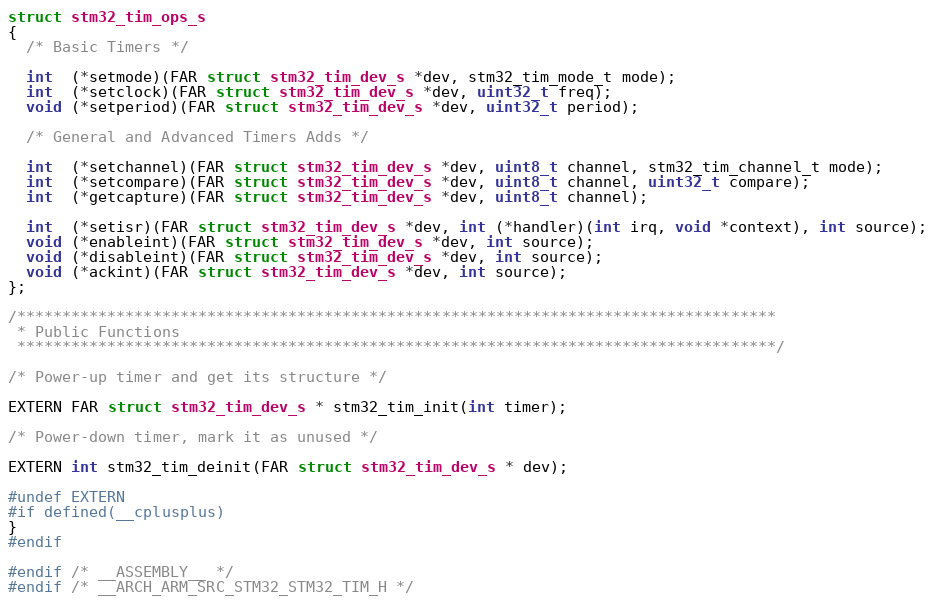<code> <loc_0><loc_0><loc_500><loc_500><_C_>struct stm32_tim_ops_s
{
  /* Basic Timers */

  int  (*setmode)(FAR struct stm32_tim_dev_s *dev, stm32_tim_mode_t mode);
  int  (*setclock)(FAR struct stm32_tim_dev_s *dev, uint32_t freq);
  void (*setperiod)(FAR struct stm32_tim_dev_s *dev, uint32_t period);

  /* General and Advanced Timers Adds */

  int  (*setchannel)(FAR struct stm32_tim_dev_s *dev, uint8_t channel, stm32_tim_channel_t mode);
  int  (*setcompare)(FAR struct stm32_tim_dev_s *dev, uint8_t channel, uint32_t compare);
  int  (*getcapture)(FAR struct stm32_tim_dev_s *dev, uint8_t channel);

  int  (*setisr)(FAR struct stm32_tim_dev_s *dev, int (*handler)(int irq, void *context), int source);
  void (*enableint)(FAR struct stm32_tim_dev_s *dev, int source);
  void (*disableint)(FAR struct stm32_tim_dev_s *dev, int source);
  void (*ackint)(FAR struct stm32_tim_dev_s *dev, int source);
};

/************************************************************************************
 * Public Functions
 ************************************************************************************/

/* Power-up timer and get its structure */

EXTERN FAR struct stm32_tim_dev_s * stm32_tim_init(int timer);

/* Power-down timer, mark it as unused */

EXTERN int stm32_tim_deinit(FAR struct stm32_tim_dev_s * dev);

#undef EXTERN
#if defined(__cplusplus)
}
#endif

#endif /* __ASSEMBLY__ */
#endif /* __ARCH_ARM_SRC_STM32_STM32_TIM_H */
</code> 